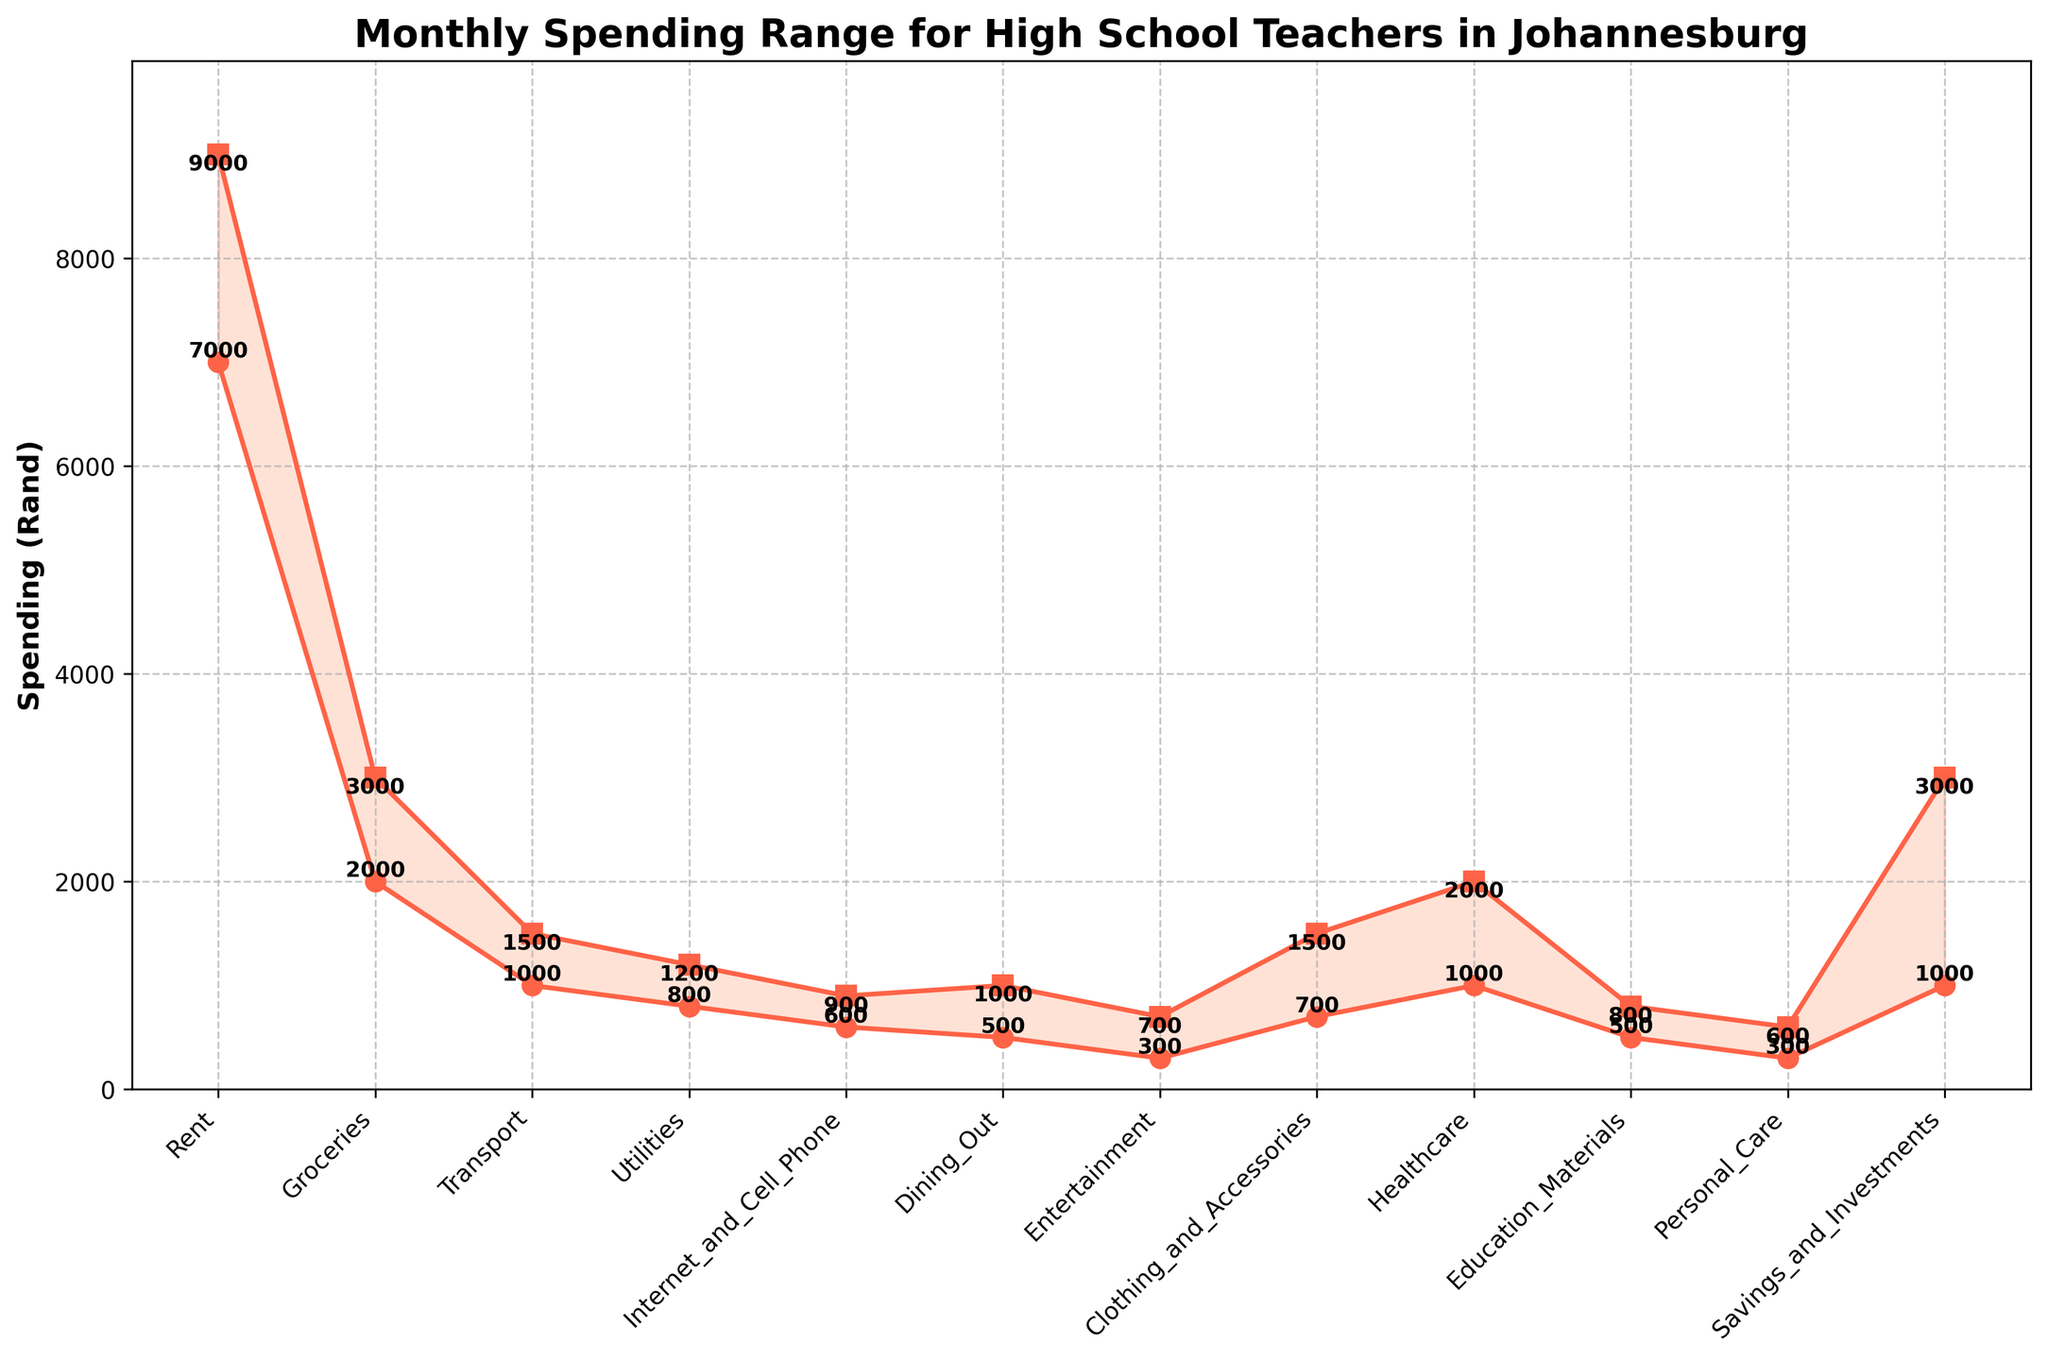What is the maximum spending range for rent? The range of spending on rent is represented by the distance between the highest and lowest points in the "Rent" category on the y-axis. The max spending is 9000, and min spending is 7000.
Answer: 9000 Rand What is the minimum spending for healthcare? To find this, look at the minimum point on the y-axis for the "Healthcare" category. It is labeled with the value next to the marker.
Answer: 1000 Rand Which category has the smallest spending range? Compare the difference between the highest and lowest spending points for all categories. The "Personal Care" category has the smallest range (300 to 600).
Answer: Personal Care What is the range of spending for dining out? The range is the difference between the maximum and minimum spending values for "Dining Out", which is 1000 - 500 = 500.
Answer: 500 Rand How much more is the maximum spending on savings and investments compared to the minimum spending on savings and investments? The difference is found by subtracting the minimum value from the maximum value for "Savings and Investments" which is 3000 - 1000 = 2000.
Answer: 2000 Rand Which category has the highest maximum spending and what is the value? The "Rent" category has the highest maximum spending at 9000 Rand.
Answer: Rent, 9000 Rand Are groceries and dining out in a similar spending range? Compare the max and min values for both categories. Groceries range from 2000 to 3000, dining out ranges from 500 to 1000. The ranges are not similar.
Answer: No Which category has a maximum spending that is equal to the maximum spending on healthcare? The maximum spending on healthcare is 2000, and savings and investments also have a maximum spending of 2000.
Answer: Savings and Investments What's the difference between maximum and minimum spending in transport? The difference is the max value minus the min value for "Transport" which is 1500 - 1000 = 500.
Answer: 500 Rand 